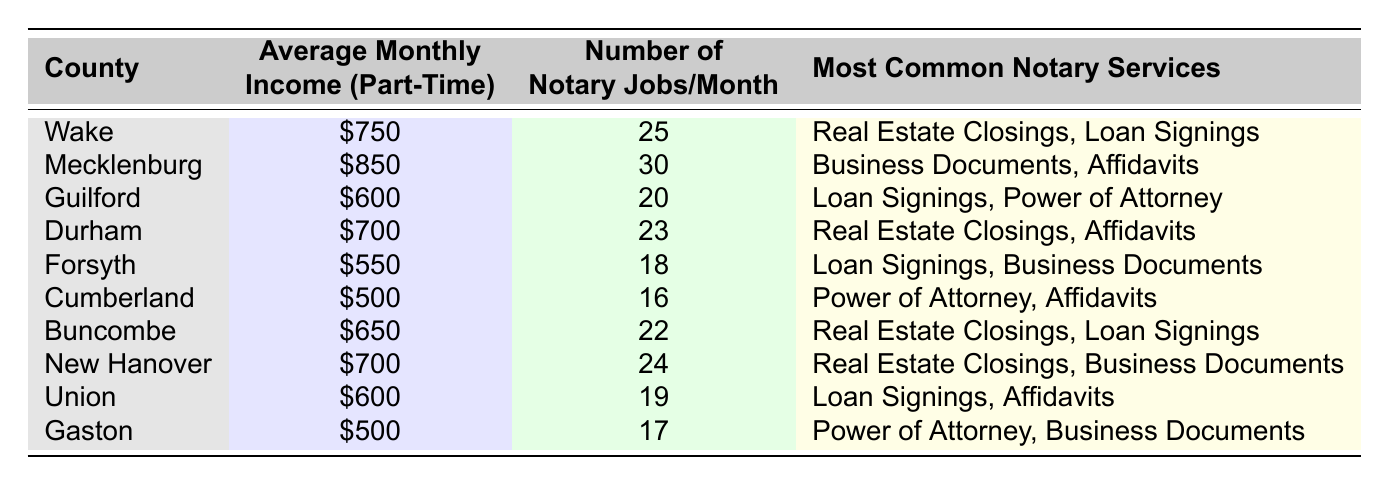What is the average monthly income for part-time notaries in Mecklenburg County? The table lists Mecklenburg County with an average monthly income of $850.
Answer: $850 Which county has the highest number of notary jobs per month? According to the table, Mecklenburg County has the highest number of notary jobs, at 30 jobs per month.
Answer: Mecklenburg What is the total average monthly income for notaries in Wake and Durham Counties combined? The average monthly income for Wake is $750 and for Durham is $700. Therefore, the total is $750 + $700 = $1450.
Answer: $1450 Is the average monthly income in Forsyth higher than in Cumberland? The table shows Forsyth's average monthly income is $550 and Cumberland's is $500, which means Forsyth's is higher.
Answer: Yes Which county offers the most common service of loan signings? The table indicates that loan signings are common in Guilford, Forsyth, Union, and Buncombe counties.
Answer: Guilford, Forsyth, Union, Buncombe What is the average monthly income for notaries in counties that provide Real Estate Closings as a service? The counties with Real Estate Closings as a service are Wake, Durham, and Buncombe, with incomes of $750, $700, and $650 respectively. The average is (750 + 700 + 650) / 3 = $716.67.
Answer: $716.67 How many notary jobs are there on average in the counties listed? The total number of notary jobs is (25 + 30 + 20 + 23 + 18 + 16 + 22 + 24 + 19 + 17) =  224. There are 10 counties, so the average is 224 / 10 = 22.4.
Answer: 22.4 In which county is the average monthly income for part-time notaries less than $600? The counties with an average monthly income less than $600 are Forsyth ($550), Cumberland ($500), and Gaston ($500).
Answer: Forsyth, Cumberland, Gaston What is the median average monthly income of all counties combined? First, list the incomes: $750, $850, $600, $700, $550, $500, $650, $700, $600, $500. When sorted ($500, $500, $550, $600, $600, $650, $700, $700, $750, $850), the median is the average of the 5th and 6th values, which are $600 and $650. Thus, the median is ($600 + $650) / 2 = $625.
Answer: $625 How does the average monthly income in Union compare to that of Buncombe? Union has an average monthly income of $600, while Buncombe's income is $650. Therefore, Buncombe has a higher income.
Answer: Buncombe has a higher income 